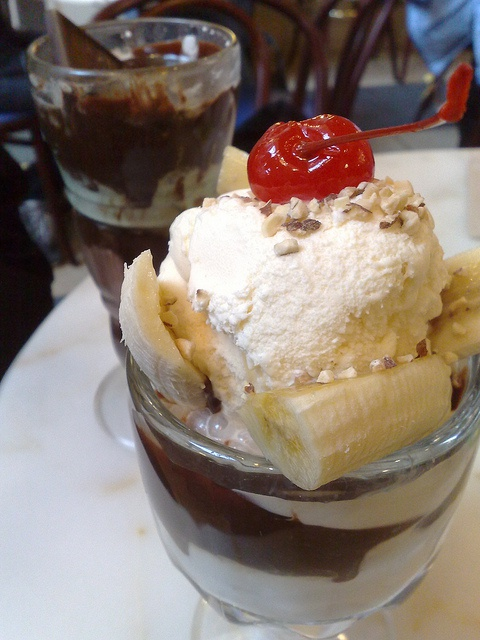Describe the objects in this image and their specific colors. I can see dining table in black, lightgray, tan, darkgray, and gray tones, bowl in black, tan, lightgray, darkgray, and gray tones, cup in black, gray, and darkgray tones, cup in black, gray, and maroon tones, and bowl in black, gray, and maroon tones in this image. 